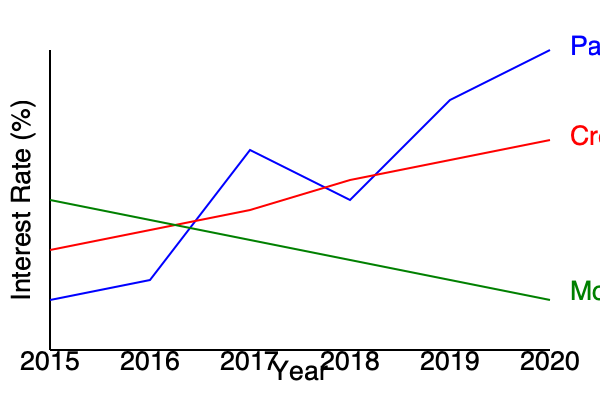Based on the interest rate trends shown in the graph, which type of loan exhibits characteristics that could be most indicative of predatory lending practices, and why might this be concerning from a consumer rights perspective? To answer this question, we need to analyze the interest rate trends for each type of loan:

1. Payday Loans (blue line):
   - Starts at the highest interest rate in 2015
   - Shows significant volatility
   - Ends with the highest rate in 2020, around 30%

2. Credit Cards (red line):
   - Starts at a moderate rate in 2015
   - Shows a gradual decrease over time
   - Ends with the second-highest rate in 2020, around 15%

3. Mortgages (green line):
   - Starts at the lowest rate in 2015
   - Shows a gradual increase over time
   - Ends with the lowest rate in 2020, around 5%

Payday loans exhibit characteristics most indicative of predatory lending practices for the following reasons:

1. Extremely high interest rates: Consistently the highest among all loan types, often exceeding 25%.
2. Volatility: The interest rates for payday loans fluctuate dramatically, suggesting unstable and potentially manipulative pricing.
3. Lack of decrease over time: Unlike credit cards, payday loan rates do not show a downward trend, indicating a lack of competitive pressure or regulatory intervention.

From a consumer rights perspective, this is concerning because:

1. Exploitation of vulnerable consumers: High-interest payday loans often target low-income individuals with limited access to traditional credit.
2. Debt traps: The high rates can lead to a cycle of debt, where borrowers struggle to repay the loan and are forced to reborrow.
3. Lack of transparency: The volatility in rates may indicate unclear or changing terms that confuse borrowers.
4. Disproportionate impact: The extreme rates can have a severe negative impact on borrowers' financial health.

These characteristics suggest that payday loans, as represented in the graph, may be structured in a way that takes unfair advantage of borrowers, which is a hallmark of predatory lending.
Answer: Payday loans, due to consistently high and volatile interest rates, potentially exploiting vulnerable consumers. 